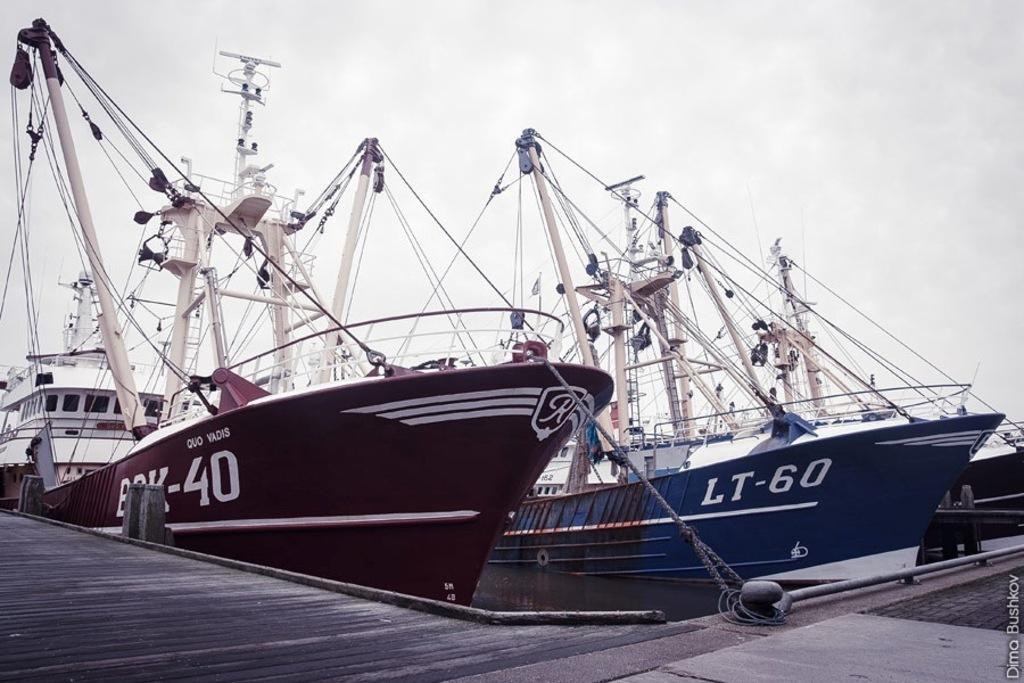What is happening in the water in the image? There are ships sailing in the water. What can be seen below the water in the image? The ground is visible in the image. What is visible above the water in the image? The sky is visible in the image. Where is the text located in the image? The text is on the bottom right corner of the image. What is the price of the owl in the image? There is no owl present in the image, so it is not possible to determine the price. What process is being used to sail the ships in the image? The image does not provide information about the process used to sail the ships; it only shows the ships sailing in the water. 